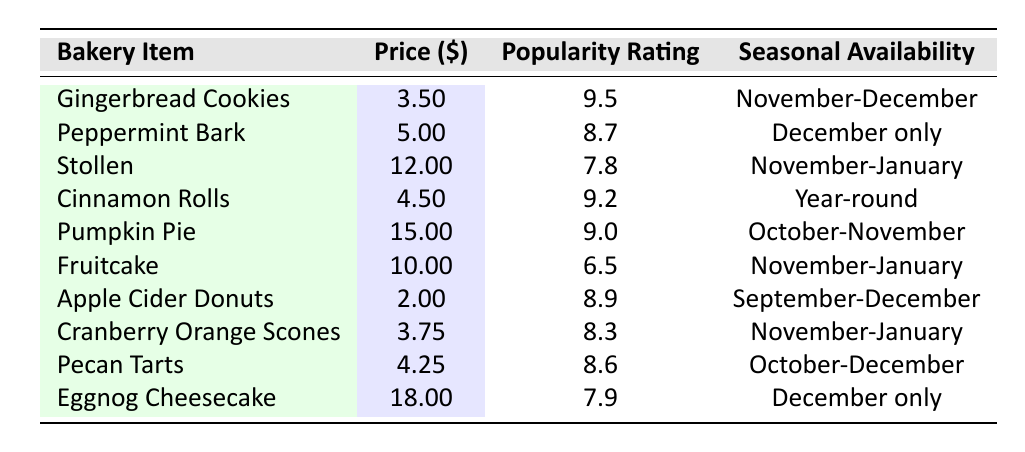What is the price of Gingerbread Cookies? The price of Gingerbread Cookies is directly listed in the table under the "Price ($)" column. Looking at the row for Gingerbread Cookies, the value is 3.50.
Answer: 3.50 What is the popularity rating of Eggnog Cheesecake? The popularity rating of Eggnog Cheesecake can be found in the table under the "Popularity Rating" column. The row for Eggnog Cheesecake shows a rating of 7.9.
Answer: 7.9 Are Cinnamon Rolls available during the holiday season? To answer this question, we need to look at the "Seasonal Availability" column for Cinnamon Rolls. The table indicates that they are available year-round, which means they are indeed available during the holiday season.
Answer: Yes Which bakery item has the highest popularity rating? The popularity ratings for each item are listed in the "Popularity Rating" column. By comparing all the values, it is clear that Gingerbread Cookies have the highest rating of 9.5.
Answer: Gingerbread Cookies What is the average price of the bakery items available from November to January? First, we identify which bakery items are available during that time period from the "Seasonal Availability" column: Stollen, Fruitcake, and Cranberry Orange Scones. Their prices are 12.00, 10.00, and 3.75 respectively. The total price is 12.00 + 10.00 + 3.75 = 25.75. There are 3 items, so the average price is 25.75 / 3 ≈ 8.58.
Answer: 8.58 How many items have a popularity rating of 8.6 or higher? We will check the "Popularity Rating" column and count how many items have ratings of 8.6 or higher. The items with those ratings are: Gingerbread Cookies (9.5), Cinnamon Rolls (9.2), Pumpkin Pie (9.0), Apple Cider Donuts (8.9), Peppermint Bark (8.7), and Pecan Tarts (8.6). This totals to 6 items.
Answer: 6 Is Fruitcake available year-round? We can find out by checking the "Seasonal Availability" for Fruitcake in the table. It shows that Fruitcake is available only from November to January. Therefore, it is not available year-round.
Answer: No What is the difference in popularity rating between Apple Cider Donuts and Pecan Tarts? We check the "Popularity Rating" for both items. Apple Cider Donuts have a rating of 8.9 and Pecan Tarts have a rating of 8.6. The difference is calculated by subtracting the lower rating from the higher. Thus, 8.9 - 8.6 = 0.3.
Answer: 0.3 